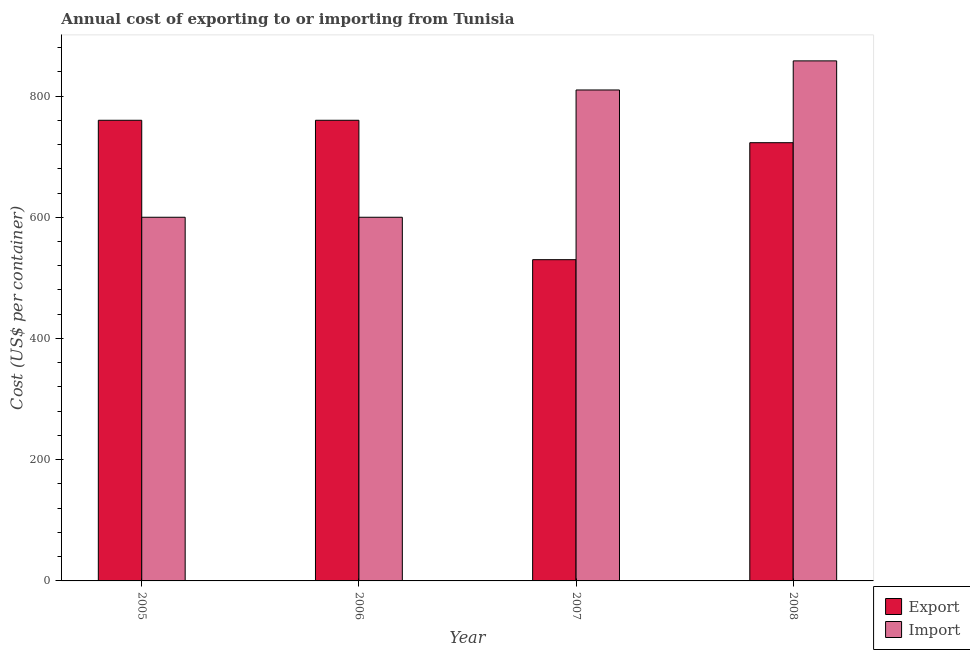How many different coloured bars are there?
Provide a succinct answer. 2. How many groups of bars are there?
Your answer should be compact. 4. Are the number of bars on each tick of the X-axis equal?
Give a very brief answer. Yes. How many bars are there on the 1st tick from the left?
Your answer should be compact. 2. How many bars are there on the 4th tick from the right?
Give a very brief answer. 2. What is the label of the 1st group of bars from the left?
Ensure brevity in your answer.  2005. What is the export cost in 2005?
Provide a short and direct response. 760. Across all years, what is the maximum import cost?
Offer a terse response. 858. Across all years, what is the minimum import cost?
Give a very brief answer. 600. In which year was the export cost maximum?
Provide a succinct answer. 2005. In which year was the export cost minimum?
Your answer should be compact. 2007. What is the total import cost in the graph?
Ensure brevity in your answer.  2868. What is the difference between the import cost in 2006 and the export cost in 2007?
Your response must be concise. -210. What is the average export cost per year?
Provide a succinct answer. 693.25. In the year 2005, what is the difference between the import cost and export cost?
Your answer should be compact. 0. What is the ratio of the import cost in 2006 to that in 2007?
Offer a very short reply. 0.74. Is the difference between the import cost in 2006 and 2008 greater than the difference between the export cost in 2006 and 2008?
Give a very brief answer. No. What is the difference between the highest and the lowest import cost?
Give a very brief answer. 258. Is the sum of the export cost in 2006 and 2007 greater than the maximum import cost across all years?
Your answer should be compact. Yes. What does the 1st bar from the left in 2008 represents?
Your answer should be compact. Export. What does the 1st bar from the right in 2006 represents?
Your answer should be very brief. Import. How many bars are there?
Offer a terse response. 8. How many years are there in the graph?
Provide a short and direct response. 4. Are the values on the major ticks of Y-axis written in scientific E-notation?
Offer a terse response. No. Does the graph contain grids?
Offer a very short reply. No. How many legend labels are there?
Your answer should be very brief. 2. How are the legend labels stacked?
Keep it short and to the point. Vertical. What is the title of the graph?
Your response must be concise. Annual cost of exporting to or importing from Tunisia. What is the label or title of the X-axis?
Keep it short and to the point. Year. What is the label or title of the Y-axis?
Your response must be concise. Cost (US$ per container). What is the Cost (US$ per container) of Export in 2005?
Offer a terse response. 760. What is the Cost (US$ per container) of Import in 2005?
Keep it short and to the point. 600. What is the Cost (US$ per container) of Export in 2006?
Your answer should be compact. 760. What is the Cost (US$ per container) in Import in 2006?
Keep it short and to the point. 600. What is the Cost (US$ per container) in Export in 2007?
Keep it short and to the point. 530. What is the Cost (US$ per container) of Import in 2007?
Ensure brevity in your answer.  810. What is the Cost (US$ per container) in Export in 2008?
Your answer should be very brief. 723. What is the Cost (US$ per container) in Import in 2008?
Offer a very short reply. 858. Across all years, what is the maximum Cost (US$ per container) in Export?
Provide a short and direct response. 760. Across all years, what is the maximum Cost (US$ per container) in Import?
Provide a short and direct response. 858. Across all years, what is the minimum Cost (US$ per container) in Export?
Your answer should be very brief. 530. Across all years, what is the minimum Cost (US$ per container) of Import?
Your answer should be compact. 600. What is the total Cost (US$ per container) in Export in the graph?
Make the answer very short. 2773. What is the total Cost (US$ per container) in Import in the graph?
Offer a terse response. 2868. What is the difference between the Cost (US$ per container) of Export in 2005 and that in 2007?
Provide a short and direct response. 230. What is the difference between the Cost (US$ per container) of Import in 2005 and that in 2007?
Offer a terse response. -210. What is the difference between the Cost (US$ per container) in Export in 2005 and that in 2008?
Your response must be concise. 37. What is the difference between the Cost (US$ per container) of Import in 2005 and that in 2008?
Provide a succinct answer. -258. What is the difference between the Cost (US$ per container) of Export in 2006 and that in 2007?
Your answer should be very brief. 230. What is the difference between the Cost (US$ per container) of Import in 2006 and that in 2007?
Give a very brief answer. -210. What is the difference between the Cost (US$ per container) in Export in 2006 and that in 2008?
Keep it short and to the point. 37. What is the difference between the Cost (US$ per container) in Import in 2006 and that in 2008?
Your answer should be compact. -258. What is the difference between the Cost (US$ per container) of Export in 2007 and that in 2008?
Provide a short and direct response. -193. What is the difference between the Cost (US$ per container) in Import in 2007 and that in 2008?
Provide a succinct answer. -48. What is the difference between the Cost (US$ per container) in Export in 2005 and the Cost (US$ per container) in Import in 2006?
Your answer should be very brief. 160. What is the difference between the Cost (US$ per container) in Export in 2005 and the Cost (US$ per container) in Import in 2008?
Your response must be concise. -98. What is the difference between the Cost (US$ per container) in Export in 2006 and the Cost (US$ per container) in Import in 2008?
Offer a terse response. -98. What is the difference between the Cost (US$ per container) in Export in 2007 and the Cost (US$ per container) in Import in 2008?
Make the answer very short. -328. What is the average Cost (US$ per container) in Export per year?
Offer a very short reply. 693.25. What is the average Cost (US$ per container) in Import per year?
Offer a very short reply. 717. In the year 2005, what is the difference between the Cost (US$ per container) in Export and Cost (US$ per container) in Import?
Provide a succinct answer. 160. In the year 2006, what is the difference between the Cost (US$ per container) of Export and Cost (US$ per container) of Import?
Provide a short and direct response. 160. In the year 2007, what is the difference between the Cost (US$ per container) of Export and Cost (US$ per container) of Import?
Provide a succinct answer. -280. In the year 2008, what is the difference between the Cost (US$ per container) of Export and Cost (US$ per container) of Import?
Ensure brevity in your answer.  -135. What is the ratio of the Cost (US$ per container) of Export in 2005 to that in 2007?
Provide a succinct answer. 1.43. What is the ratio of the Cost (US$ per container) of Import in 2005 to that in 2007?
Provide a short and direct response. 0.74. What is the ratio of the Cost (US$ per container) in Export in 2005 to that in 2008?
Provide a succinct answer. 1.05. What is the ratio of the Cost (US$ per container) of Import in 2005 to that in 2008?
Provide a short and direct response. 0.7. What is the ratio of the Cost (US$ per container) of Export in 2006 to that in 2007?
Your answer should be very brief. 1.43. What is the ratio of the Cost (US$ per container) of Import in 2006 to that in 2007?
Ensure brevity in your answer.  0.74. What is the ratio of the Cost (US$ per container) in Export in 2006 to that in 2008?
Give a very brief answer. 1.05. What is the ratio of the Cost (US$ per container) of Import in 2006 to that in 2008?
Provide a succinct answer. 0.7. What is the ratio of the Cost (US$ per container) of Export in 2007 to that in 2008?
Ensure brevity in your answer.  0.73. What is the ratio of the Cost (US$ per container) of Import in 2007 to that in 2008?
Offer a terse response. 0.94. What is the difference between the highest and the second highest Cost (US$ per container) in Import?
Your answer should be compact. 48. What is the difference between the highest and the lowest Cost (US$ per container) of Export?
Provide a short and direct response. 230. What is the difference between the highest and the lowest Cost (US$ per container) of Import?
Provide a short and direct response. 258. 